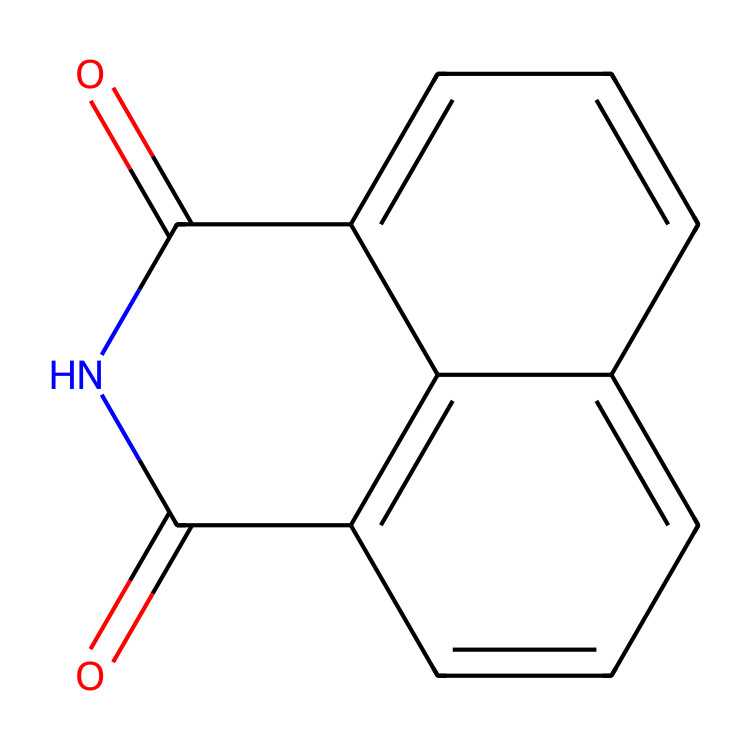What is the molecular formula of naphthalimide? The molecular formula can be determined by counting the number of carbon (C), hydrogen (H), nitrogen (N), and oxygen (O) atoms in the SMILES. In this case, there are 12 carbon atoms, 7 hydrogen atoms, 2 nitrogen atoms, and 2 oxygen atoms, leading to the formula C12H7N2O2.
Answer: C12H7N2O2 How many rings are present in naphthalimide's structure? By examining the chemical structure provided in the SMILES, we can see that the compound consists of multiple interconnected carbon atoms forming two fused aromatic rings, typical of an imide structure. Therefore, there are two rings in total.
Answer: 2 rings What atoms are characteristic of imides in the structure? The presence of the imide functional group is indicated by the nitrogen atoms bonded to carbonyl groups (C=O). In this structure, the two nitrogen atoms bonded to carbonyls confirm it as an imide.
Answer: Nitrogen and carbonyl How many carbonyl groups are present in naphthalimide? Counting the carbonyls (C=O) in the structure from the provided SMILES representation shows two carbonyl groups are attached to the nitrogen atoms, which are indicative of the imide functionality in this compound.
Answer: 2 carbonyl groups What two elements are involved in the formation of the cyclic structure of naphthalimide? The cyclic structure of naphthalimide is formed by the connection of carbon and nitrogen atoms through the bonds of a five-membered ring, which includes nitrogen and carbon atoms in its structure.
Answer: Carbon and nitrogen What is the degree of unsaturation in naphthalimide? The degree of unsaturation can be calculated by using the formula (2C + 2 + N - H - X)/2. Substituting the values (C=12, H=7, N=2) yields (2*12 + 2 + 2 - 7 - 0)/2 = 10, indicating a high degree of unsaturation due to double bonds and cyclic structure.
Answer: 10 